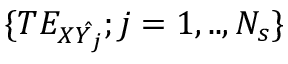<formula> <loc_0><loc_0><loc_500><loc_500>\{ T E _ { X \hat { Y _ { j } } } ; j = 1 , . . , N _ { s } \}</formula> 